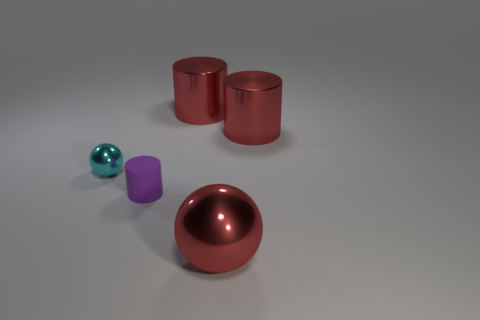Subtract all large red metallic cylinders. How many cylinders are left? 1 Add 1 blue rubber cylinders. How many objects exist? 6 Subtract all red cylinders. How many cylinders are left? 1 Subtract all cylinders. How many objects are left? 2 Subtract all large blue shiny objects. Subtract all big cylinders. How many objects are left? 3 Add 2 large red objects. How many large red objects are left? 5 Add 3 small balls. How many small balls exist? 4 Subtract 0 green cubes. How many objects are left? 5 Subtract 2 cylinders. How many cylinders are left? 1 Subtract all green cylinders. Subtract all brown blocks. How many cylinders are left? 3 